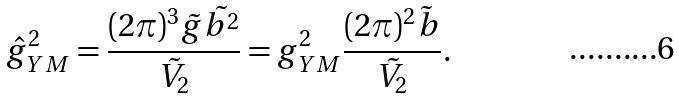<formula> <loc_0><loc_0><loc_500><loc_500>\hat { g } _ { Y M } ^ { 2 } = \frac { ( 2 \pi ) ^ { 3 } \tilde { g } \tilde { b ^ { 2 } } } { \tilde { V } _ { 2 } } = g _ { Y M } ^ { 2 } \frac { ( 2 \pi ) ^ { 2 } \tilde { b } } { \tilde { V } _ { 2 } } .</formula> 